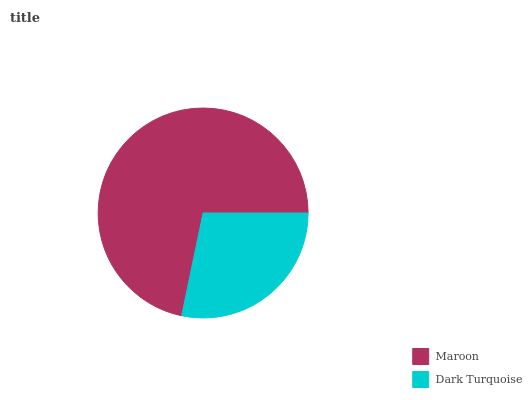Is Dark Turquoise the minimum?
Answer yes or no. Yes. Is Maroon the maximum?
Answer yes or no. Yes. Is Dark Turquoise the maximum?
Answer yes or no. No. Is Maroon greater than Dark Turquoise?
Answer yes or no. Yes. Is Dark Turquoise less than Maroon?
Answer yes or no. Yes. Is Dark Turquoise greater than Maroon?
Answer yes or no. No. Is Maroon less than Dark Turquoise?
Answer yes or no. No. Is Maroon the high median?
Answer yes or no. Yes. Is Dark Turquoise the low median?
Answer yes or no. Yes. Is Dark Turquoise the high median?
Answer yes or no. No. Is Maroon the low median?
Answer yes or no. No. 